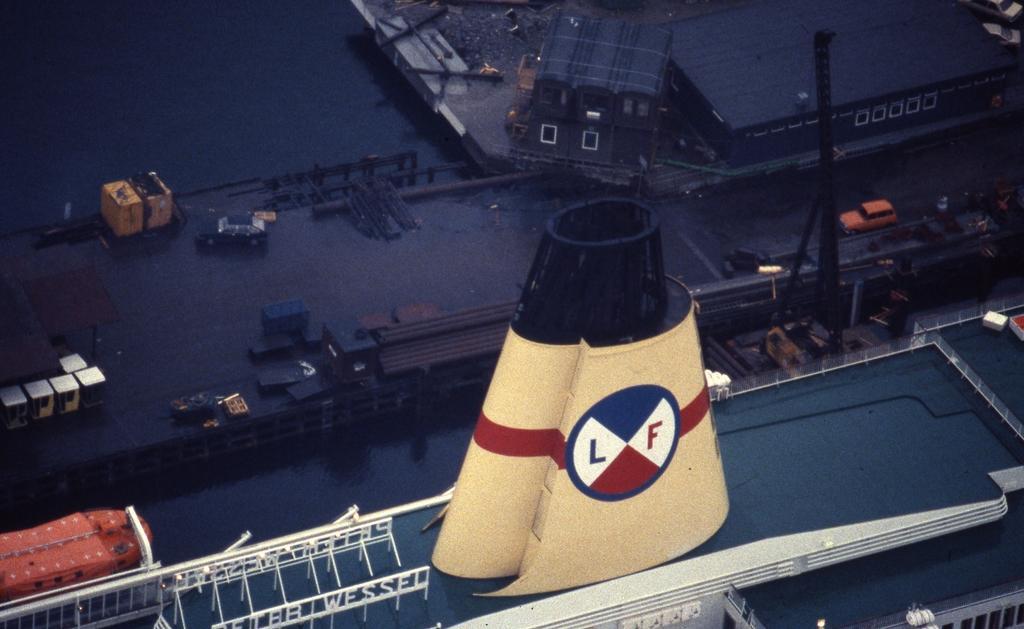Could you give a brief overview of what you see in this image? In this image we can see a ship. On the ship there is an object with a logo. Also we can see water. There is a lifeboat. And there is a port. And we can see cars. Also there is a crane. And there are few other things. 